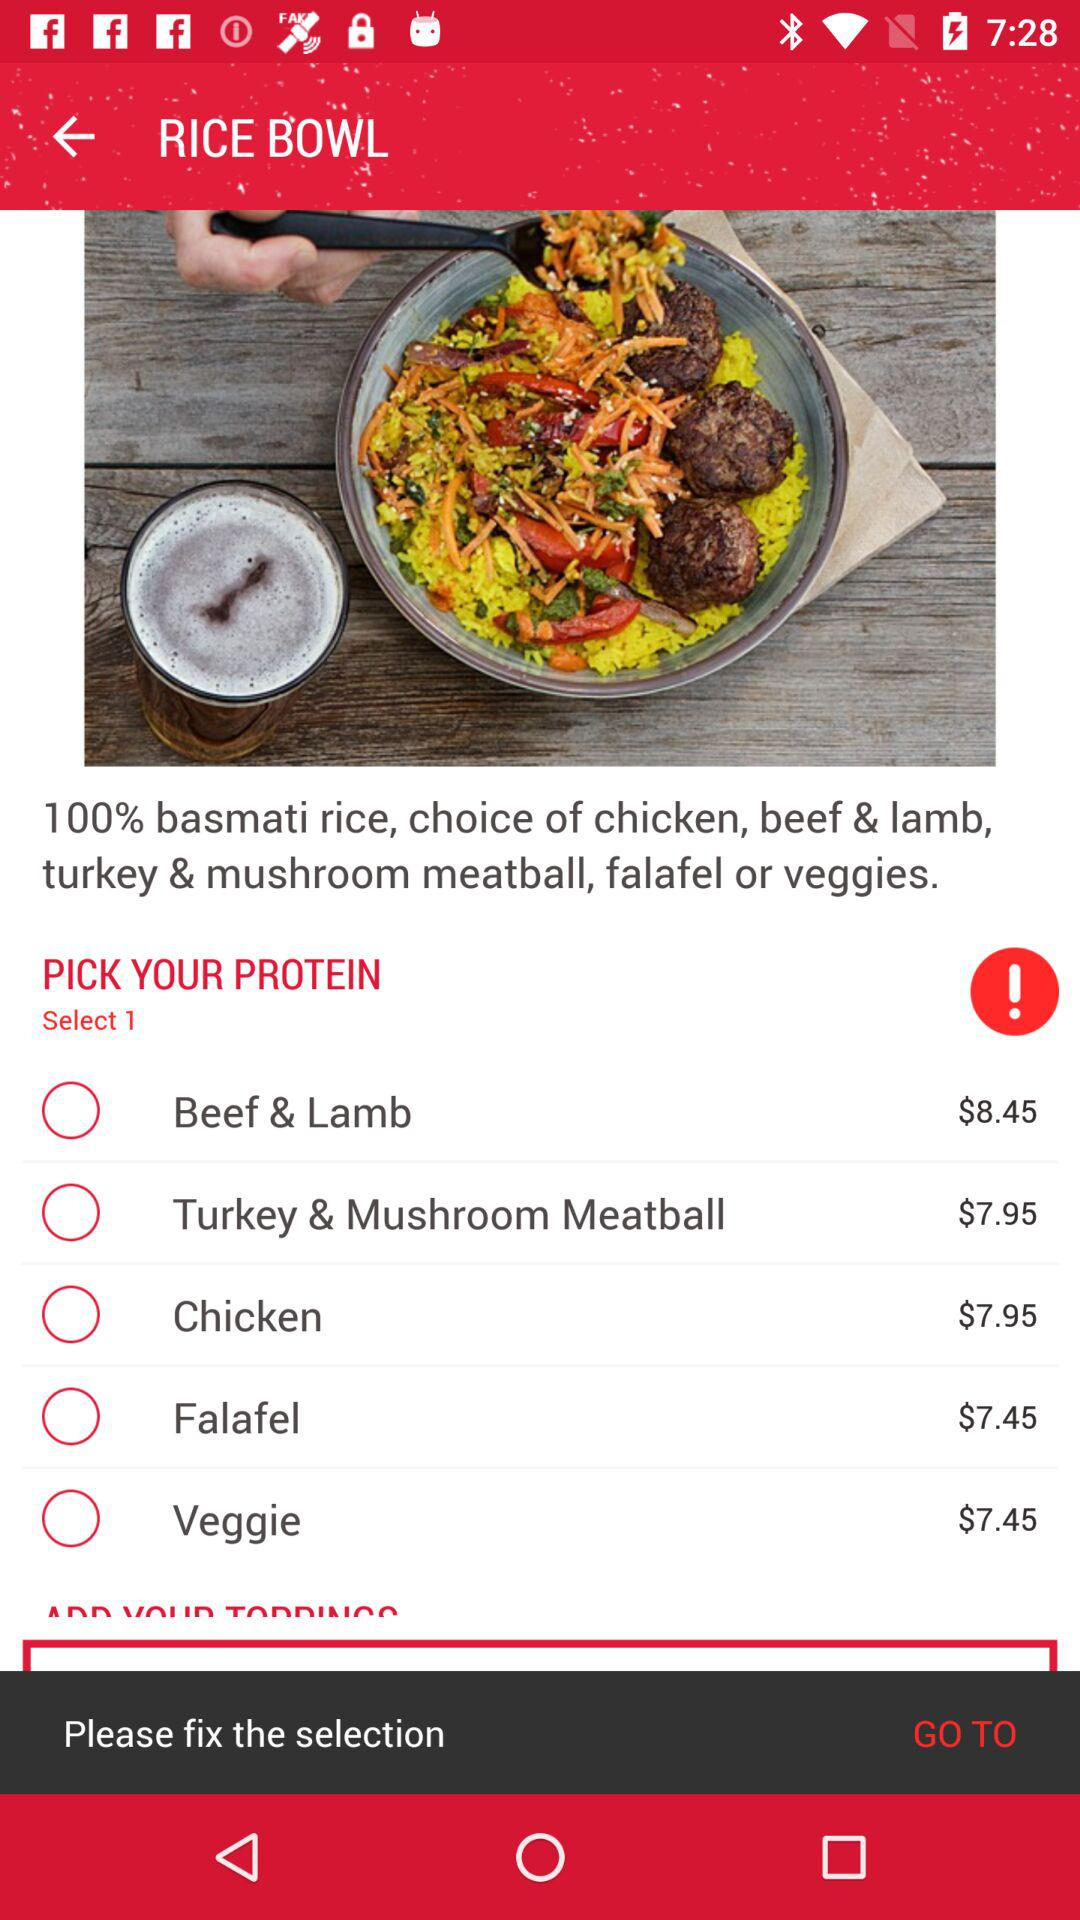How many types of protein are there?
Answer the question using a single word or phrase. 5 